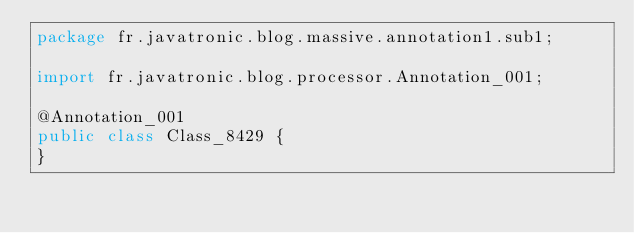Convert code to text. <code><loc_0><loc_0><loc_500><loc_500><_Java_>package fr.javatronic.blog.massive.annotation1.sub1;

import fr.javatronic.blog.processor.Annotation_001;

@Annotation_001
public class Class_8429 {
}
</code> 